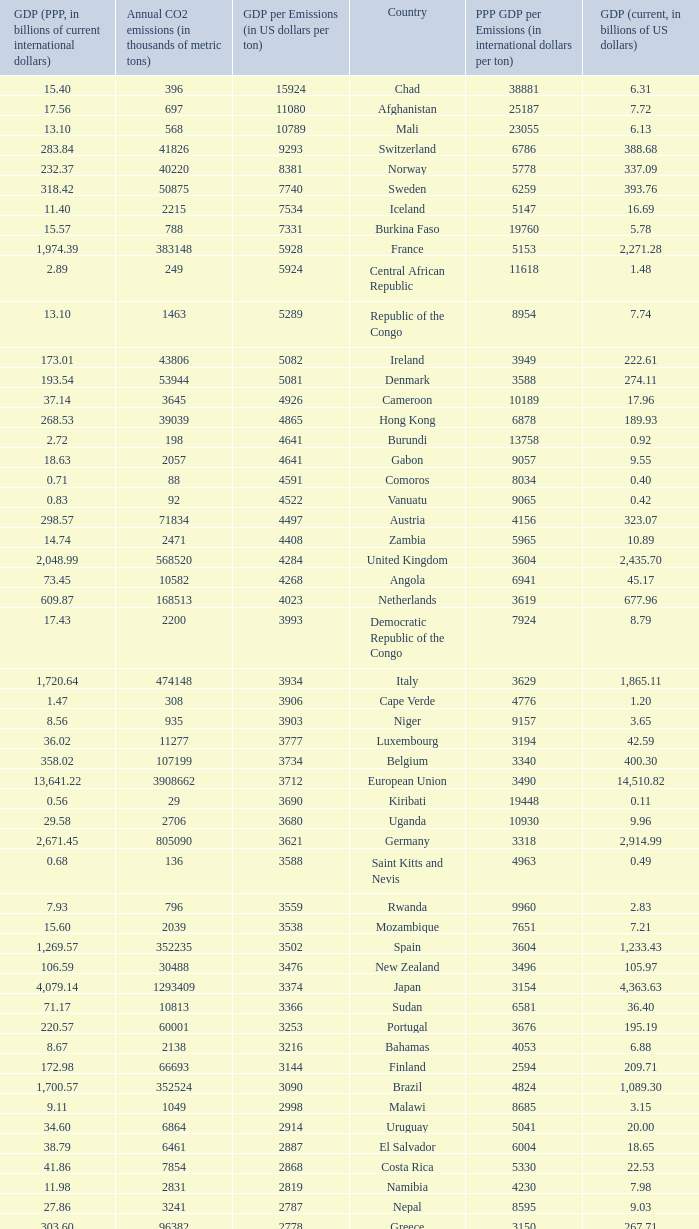93, what is the top ppp gdp per emissions (in international dollars per ton)? 9960.0. Can you give me this table as a dict? {'header': ['GDP (PPP, in billions of current international dollars)', 'Annual CO2 emissions (in thousands of metric tons)', 'GDP per Emissions (in US dollars per ton)', 'Country', 'PPP GDP per Emissions (in international dollars per ton)', 'GDP (current, in billions of US dollars)'], 'rows': [['15.40', '396', '15924', 'Chad', '38881', '6.31'], ['17.56', '697', '11080', 'Afghanistan', '25187', '7.72'], ['13.10', '568', '10789', 'Mali', '23055', '6.13'], ['283.84', '41826', '9293', 'Switzerland', '6786', '388.68'], ['232.37', '40220', '8381', 'Norway', '5778', '337.09'], ['318.42', '50875', '7740', 'Sweden', '6259', '393.76'], ['11.40', '2215', '7534', 'Iceland', '5147', '16.69'], ['15.57', '788', '7331', 'Burkina Faso', '19760', '5.78'], ['1,974.39', '383148', '5928', 'France', '5153', '2,271.28'], ['2.89', '249', '5924', 'Central African Republic', '11618', '1.48'], ['13.10', '1463', '5289', 'Republic of the Congo', '8954', '7.74'], ['173.01', '43806', '5082', 'Ireland', '3949', '222.61'], ['193.54', '53944', '5081', 'Denmark', '3588', '274.11'], ['37.14', '3645', '4926', 'Cameroon', '10189', '17.96'], ['268.53', '39039', '4865', 'Hong Kong', '6878', '189.93'], ['2.72', '198', '4641', 'Burundi', '13758', '0.92'], ['18.63', '2057', '4641', 'Gabon', '9057', '9.55'], ['0.71', '88', '4591', 'Comoros', '8034', '0.40'], ['0.83', '92', '4522', 'Vanuatu', '9065', '0.42'], ['298.57', '71834', '4497', 'Austria', '4156', '323.07'], ['14.74', '2471', '4408', 'Zambia', '5965', '10.89'], ['2,048.99', '568520', '4284', 'United Kingdom', '3604', '2,435.70'], ['73.45', '10582', '4268', 'Angola', '6941', '45.17'], ['609.87', '168513', '4023', 'Netherlands', '3619', '677.96'], ['17.43', '2200', '3993', 'Democratic Republic of the Congo', '7924', '8.79'], ['1,720.64', '474148', '3934', 'Italy', '3629', '1,865.11'], ['1.47', '308', '3906', 'Cape Verde', '4776', '1.20'], ['8.56', '935', '3903', 'Niger', '9157', '3.65'], ['36.02', '11277', '3777', 'Luxembourg', '3194', '42.59'], ['358.02', '107199', '3734', 'Belgium', '3340', '400.30'], ['13,641.22', '3908662', '3712', 'European Union', '3490', '14,510.82'], ['0.56', '29', '3690', 'Kiribati', '19448', '0.11'], ['29.58', '2706', '3680', 'Uganda', '10930', '9.96'], ['2,671.45', '805090', '3621', 'Germany', '3318', '2,914.99'], ['0.68', '136', '3588', 'Saint Kitts and Nevis', '4963', '0.49'], ['7.93', '796', '3559', 'Rwanda', '9960', '2.83'], ['15.60', '2039', '3538', 'Mozambique', '7651', '7.21'], ['1,269.57', '352235', '3502', 'Spain', '3604', '1,233.43'], ['106.59', '30488', '3476', 'New Zealand', '3496', '105.97'], ['4,079.14', '1293409', '3374', 'Japan', '3154', '4,363.63'], ['71.17', '10813', '3366', 'Sudan', '6581', '36.40'], ['220.57', '60001', '3253', 'Portugal', '3676', '195.19'], ['8.67', '2138', '3216', 'Bahamas', '4053', '6.88'], ['172.98', '66693', '3144', 'Finland', '2594', '209.71'], ['1,700.57', '352524', '3090', 'Brazil', '4824', '1,089.30'], ['9.11', '1049', '2998', 'Malawi', '8685', '3.15'], ['34.60', '6864', '2914', 'Uruguay', '5041', '20.00'], ['38.79', '6461', '2887', 'El Salvador', '6004', '18.65'], ['41.86', '7854', '2868', 'Costa Rica', '5330', '22.53'], ['11.98', '2831', '2819', 'Namibia', '4230', '7.98'], ['27.86', '3241', '2787', 'Nepal', '8595', '9.03'], ['303.60', '96382', '2778', 'Greece', '3150', '267.71'], ['0.95', '158', '2747', 'Samoa', '5987', '0.43'], ['0.66', '117', '2709', 'Dominica', '5632', '0.32'], ['35.22', '7462', '2672', 'Latvia', '4720', '19.94'], ['44.46', '5372', '2671', 'Tanzania', '8276', '14.35'], ['10.52', '1811', '2670', 'Haiti', '5809', '4.84'], ['30.21', '6428', '2666', 'Panama', '4700', '17.13'], ['5.18', '1016', '2629', 'Swaziland', '5095', '2.67'], ['57.77', '11766', '2572', 'Guatemala', '4910', '30.26'], ['51.14', '15173', '2566', 'Slovenia', '3370', '38.94'], ['342.77', '63422', '2562', 'Colombia', '5405', '162.50'], ['8.88', '2548', '2528', 'Malta', '3485', '6.44'], ['31.22', '6882', '2526', 'Ivory Coast', '4536', '17.38'], ['54.39', '6006', '2525', 'Ethiopia', '9055', '15.17'], ['1.69', '367', '2520', 'Saint Lucia', '4616', '0.93'], ['0.96', '198', '2515', 'Saint Vincent and the Grenadines', '4843', '0.50'], ['208.75', '56217', '2476', 'Singapore', '3713', '139.18'], ['11.41', '1426', '2459', 'Laos', '8000', '3.51'], ['2.61', '381', '2444', 'Bhutan', '6850', '0.93'], ['214.41', '60100', '2442', 'Chile', '3568', '146.76'], ['195.99', '38643', '2389', 'Peru', '5072', '92.31'], ['4.80', '1338', '2385', 'Barbados', '3590', '3.19'], ['77.51', '11876', '2381', 'Sri Lanka', '6526', '28.28'], ['23.51', '4770', '2369', 'Botswana', '4929', '11.30'], ['1.41', '425', '2367', 'Antigua and Barbuda', '3315', '1.01'], ['19.99', '7788', '2366', 'Cyprus', '2566', '18.43'], ['1,203.74', '544680', '2348', 'Canada', '2210', '1,278.97'], ['1.05', '242', '2331', 'Grenada', '4331', '0.56'], ['24.81', '3986', '2327', 'Paraguay', '6224', '9.28'], ['13,178.35', '5752289', '2291', 'United States', '2291', '13,178.35'], ['15.76', '4356', '2205', 'Equatorial Guinea', '3618', '9.60'], ['19.30', '4261', '2198', 'Senegal', '4529', '9.37'], ['3.48', '554', '2186', 'Eritrea', '6283', '1.21'], ['1,408.81', '436150', '2184', 'Mexico', '3230', '952.34'], ['9.29', '1360', '2135', 'Guinea', '6829', '2.90'], ['54.04', '14190', '2120', 'Lithuania', '3808', '30.08'], ['18.34', '4301', '2119', 'Albania', '4264', '9.11'], ['72.63', '23683', '2071', 'Croatia', '3067', '49.04'], ['174.61', '70440', '2044', 'Israel', '2479', '143.98'], ['713.96', '372013', '2030', 'Australia', '1919', '755.21'], ['1,190.70', '475248', '2003', 'South Korea', '2505', '952.03'], ['3.74', '1610', '1967', 'Fiji', '2320', '3.17'], ['824.58', '269452', '1964', 'Turkey', '3060', '529.19'], ['183.84', '57644', '1961', 'Hungary', '3189', '113.05'], ['16.84', '2834', '1947', 'Madagascar', '5943', '5.52'], ['18.93', '5911', '1940', 'Brunei', '3203', '11.47'], ['1.96', '176', '1858', 'Timor-Leste', '11153', '0.33'], ['0.86', '180', '1856', 'Solomon Islands', '4789', '0.33'], ['52.74', '12151', '1853', 'Kenya', '4340', '22.52'], ['4.96', '1221', '1818', 'Togo', '4066', '2.22'], ['0.54', '132', '1788', 'Tonga', '4076', '0.24'], ['23.03', '4074', '1783', 'Cambodia', '5653', '7.26'], ['63.94', '20357', '1733', 'Dominican Republic', '3141', '35.28'], ['272.25', '68328', '1721', 'Philippines', '3984', '117.57'], ['37.37', '6973', '1653', 'Bolivia', '5359', '11.53'], ['13.09', '3850', '1641', 'Mauritius', '3399', '6.32'], ['5.74', '1665', '1621', 'Mauritania', '3448', '2.70'], ['1.61', '488', '1576', 'Djibouti', '3297', '0.77'], ['190.93', '41609', '1567', 'Bangladesh', '4589', '65.20'], ['11.29', '3109', '1524', 'Benin', '3631', '4.74'], ['1.92', '334', '1521', 'Gambia', '5743', '0.51'], ['268.21', '97262', '1510', 'Nigeria', '2758', '146.89'], ['28.20', '7194', '1507', 'Honduras', '3920', '10.84'], ['96.76', '37459', '1495', 'Slovakia', '2583', '56.00'], ['2.31', '818', '1483', 'Belize', '2823', '1.21'], ['40.46', '15330', '1464', 'Lebanon', '2639', '22.44'], ['14.68', '4371', '1461', 'Armenia', '3357', '6.38'], ['120.32', '45316', '1448', 'Morocco', '2655', '65.64'], ['55.55', '10025', '1447', 'Burma', '5541', '14.50'], ['3.62', '994', '1433', 'Sierra Leone', '3644', '1.42'], ['17.77', '5518', '1408', 'Georgia', '3221', '7.77'], ['28.72', '9240', '1378', 'Ghana', '3108', '12.73'], ['70.57', '23126', '1345', 'Tunisia', '3052', '31.11'], ['94.48', '31328', '1322', 'Ecuador', '3016', '41.40'], ['1.61', '744', '1301', 'Seychelles', '2157', '0.97'], ['226.51', '98490', '1246', 'Romania', '2300', '122.70'], ['66.90', '46193', '1232', 'Qatar', '1448', '56.92'], ['469.75', '173536', '1226', 'Argentina', '2707', '212.71'], ['228.48', '116991', '1216', 'Czech Republic', '1953', '142.31'], ['14.93', '4334', '1215', 'Nicaragua', '3444', '5.26'], ['0.24', '103', '1214', 'São Tomé and Príncipe', '2311', '0.13'], ['10.91', '4620', '1213', 'Papua New Guinea', '2361', '5.61'], ['154.35', '139553', '1176', 'United Arab Emirates', '1106', '164.17'], ['119.96', '86599', '1173', 'Kuwait', '1385', '101.56'], ['0.76', '279', '1136', 'Guinea-Bissau', '2724', '0.32'], ['767.92', '333483', '1093', 'Indonesia', '2303', '364.35'], ['300.80', '171593', '1074', 'Venezuela', '1753', '184.25'], ['567.94', '318219', '1074', 'Poland', '1785', '341.67'], ['1.44', '869', '1053', 'Maldives', '1654', '0.92'], ['75.47', '55495', '992', 'Libya', '1360', '55.08'], ['19.93', '12151', '942', 'Jamaica', '1640', '11.45'], ['25.31', '17523', '939', 'Estonia', '1444', '16.45'], ['522.12', '381564', '935', 'Saudi Arabia', '1368', '356.63'], ['49.21', '21201', '899', 'Yemen', '2321', '19.06'], ['372.96', '142659', '894', 'Pakistan', '2614', '127.49'], ['209.40', '132715', '880', 'Algeria', '1578', '116.83'], ['3.76', '2438', '878', 'Suriname', '1543', '2.14'], ['56.44', '41378', '863', 'Oman', '1364', '35.73'], ['328.97', '187865', '835', 'Malaysia', '1751', '156.86'], ['1.19', '785', '780', 'Liberia', '1520', '0.61'], ['483.56', '272521', '760', 'Thailand', '1774', '206.99'], ['22.41', '21292', '744', 'Bahrain', '1053', '15.85'], ['26.25', '20724', '716', 'Jordan', '1266', '14.84'], ['79.24', '48085', '659', 'Bulgaria', '1648', '31.69'], ['367.64', '166800', '644', 'Egypt', '2204', '107.38'], ['1,887.61', '1564669', '632', 'Russia', '1206', '989.43'], ['433.51', '414649', '622', 'South Africa', '1045', '257.89'], ['72.93', '53266', '606', 'Serbia and Montenegro', '1369', '32.30'], ['2.70', '1507', '606', 'Guyana', '1792', '0.91'], ['51.71', '35050', '600', 'Azerbaijan', '1475', '21.03'], ['16.14', '10875', '587', 'Macedonia', '1484', '6.38'], ['2,672.66', '1510351', '579', 'India', '1770', '874.77'], ['23.62', '33601', '577', 'Trinidad and Tobago', '703', '19.38'], ['198.94', '106132', '574', 'Vietnam', '1874', '60.93'], ['94.80', '68849', '537', 'Belarus', '1377', '36.96'], ['90.51', '92572', '532', 'Iraq', '978', '49.27'], ['9.45', '5566', '510', 'Kyrgyzstan', '1698', '2.84'], ['2.29', '11081', '505', 'Zimbabwe', '207', '5.60'], ['82.09', '68460', '489', 'Syria', '1199', '33.51'], ['23.40', '44103', '485', 'Turkmenistan', '531', '21.40'], ['693.32', '466976', '476', 'Iran', '1485', '222.13'], ['25.70', '27438', '447', 'Bosnia and Herzegovina', '937', '12.28'], ['10.69', '6391', '440', 'Tajikistan', '1672', '2.81'], ['9.19', '7821', '436', 'Moldova', '1175', '3.41'], ['6,122.24', '6103493', '435', 'China', '1003', '2,657.84'], ['150.56', '193508', '419', 'Kazakhstan', '778', '81.00'], ['291.30', '319158', '338', 'Ukraine', '913', '108.00'], ['7.47', '9442', '334', 'Mongolia', '791', '3.16']]} 